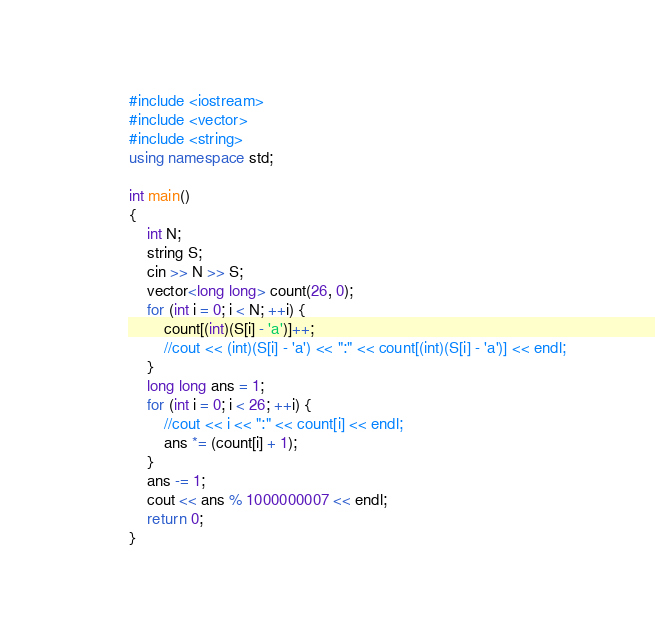<code> <loc_0><loc_0><loc_500><loc_500><_C++_>#include <iostream>
#include <vector>
#include <string>
using namespace std;

int main()
{
	int N;
	string S;
	cin >> N >> S;
	vector<long long> count(26, 0);
	for (int i = 0; i < N; ++i) {
		count[(int)(S[i] - 'a')]++;
		//cout << (int)(S[i] - 'a') << ":" << count[(int)(S[i] - 'a')] << endl;
	}
	long long ans = 1;
	for (int i = 0; i < 26; ++i) {
		//cout << i << ":" << count[i] << endl;
		ans *= (count[i] + 1);
	}
	ans -= 1;
	cout << ans % 1000000007 << endl;
	return 0;
}
</code> 